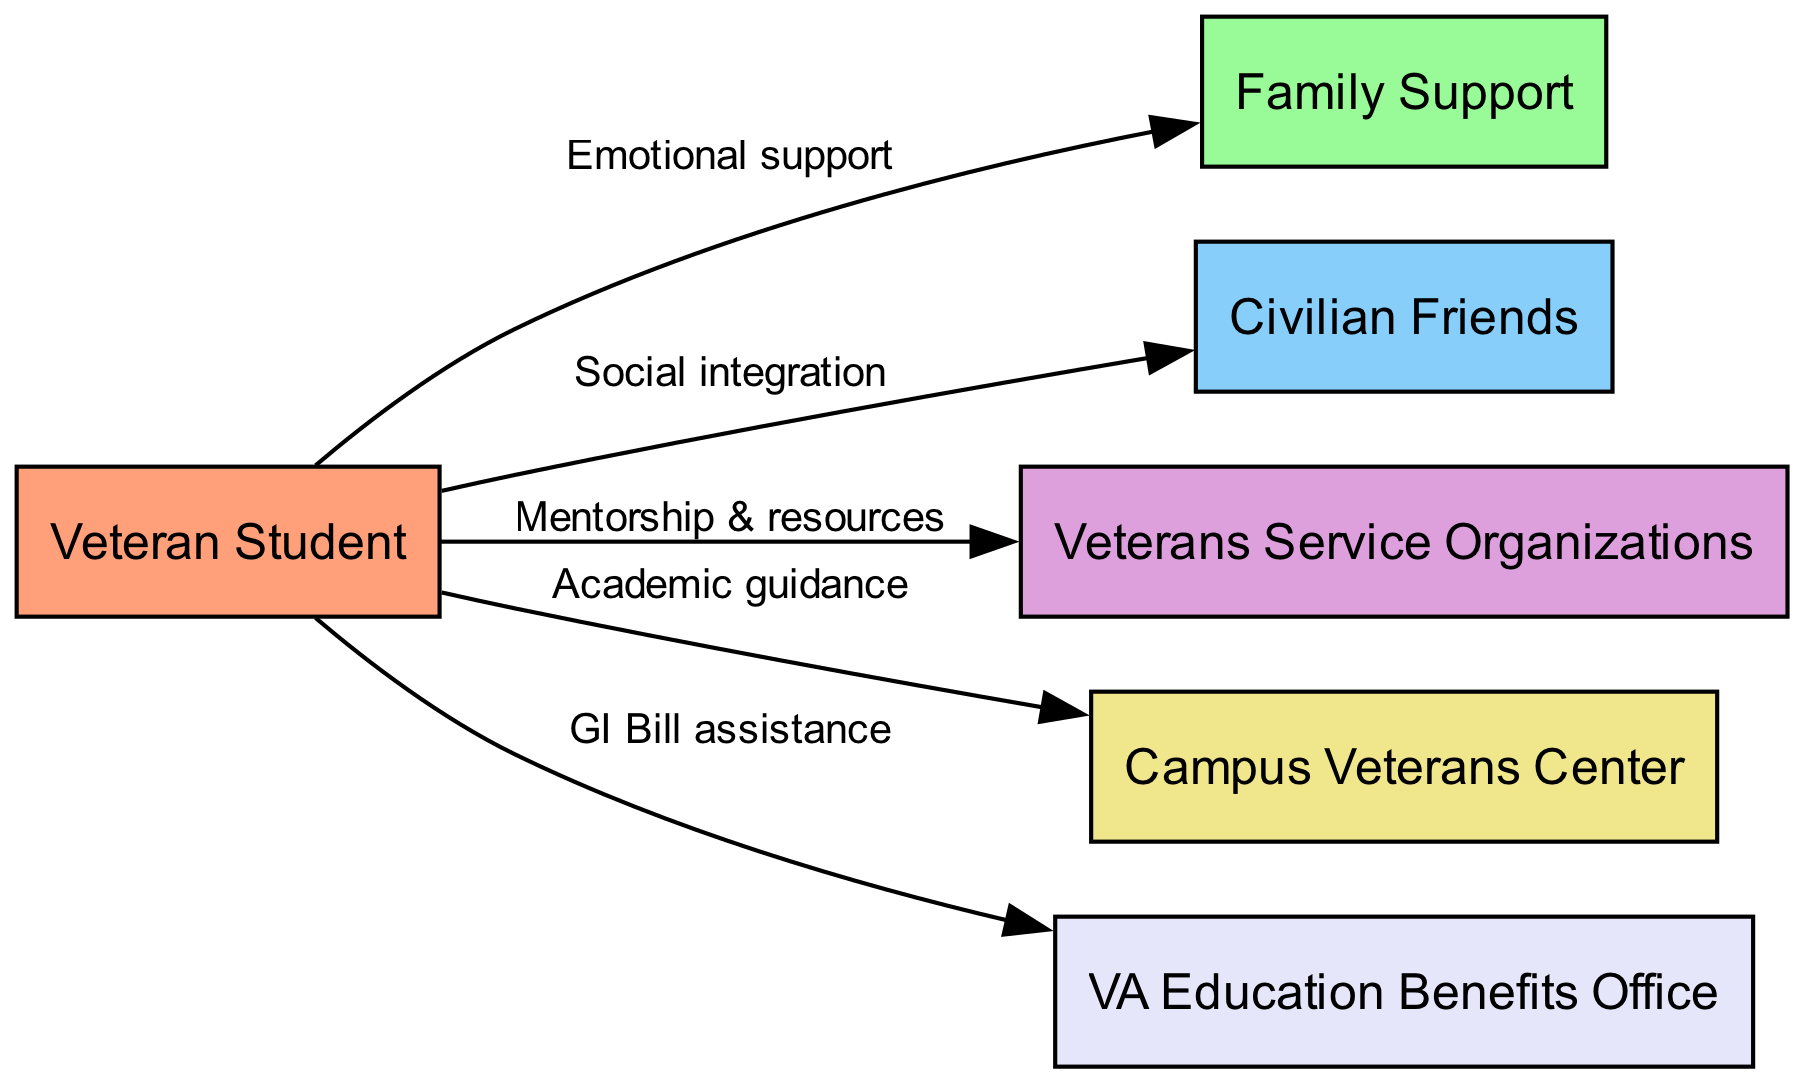What is the label for the node representing 'Veterans Service Organizations'? In the diagram, each node has an ID and a label. The node with the ID 'vso' is labeled as 'Veterans Service Organizations'.
Answer: Veterans Service Organizations How many edges are there in the diagram? The diagram indicates connections between nodes called edges. By counting the list of edges provided in the data, we find there are five edges.
Answer: 5 What type of support is provided by the 'Family Support' node to the 'Veteran Student'? The edge connecting the 'veteran' node to the 'family' node is labeled as 'Emotional support', indicating that this is the type of support provided.
Answer: Emotional support Which node is connected to the 'Veteran Student' node for 'GI Bill assistance'? The diagram shows a direct connection from the 'veteran' node to the 'va' node, which is labeled as 'GI Bill assistance'.
Answer: VA Education Benefits Office What is one way the 'Veterans Service Organizations' help 'Veteran Students'? The edge from the 'vso' node to the 'veteran' node is labeled 'Mentorship & resources', which outlines how this organization assists veterans.
Answer: Mentorship & resources Which node provides 'Academic guidance' to the 'Veteran Student'? The edge leading from the 'campus' node to the 'veteran' node is labeled 'Academic guidance', showing that this is the source of such guidance.
Answer: Campus Veterans Center What is the relationship between 'Civilian Friends' and 'Veteran Students'? The relationship is indicated by the edge labeled 'Social integration' connecting the 'friends' node to the 'veteran' node.
Answer: Social integration How many nodes are related to the 'Veteran Student'? By examining the diagram, we find the 'veteran' node is connected to five different nodes: 'Family Support', 'Civilian Friends', 'Veterans Service Organizations', 'Campus Veterans Center', and 'VA Education Benefits Office', totaling five nodes.
Answer: 5 